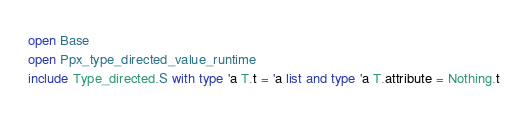<code> <loc_0><loc_0><loc_500><loc_500><_OCaml_>open Base
open Ppx_type_directed_value_runtime
include Type_directed.S with type 'a T.t = 'a list and type 'a T.attribute = Nothing.t
</code> 